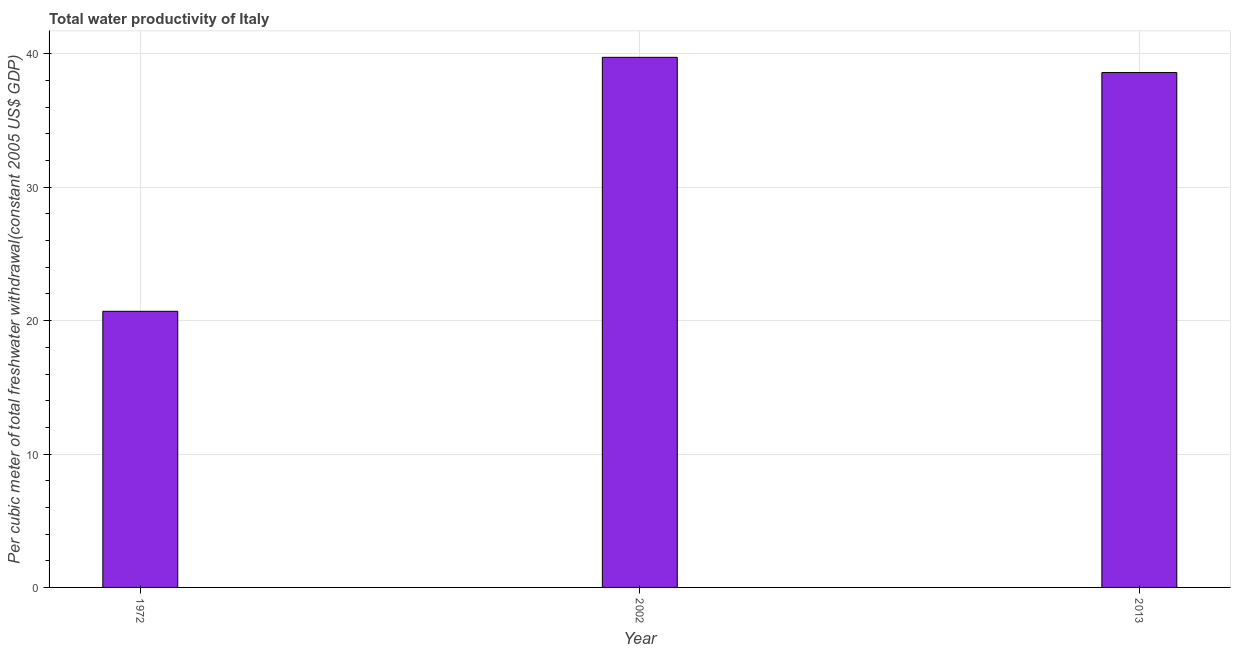Does the graph contain grids?
Offer a very short reply. Yes. What is the title of the graph?
Provide a succinct answer. Total water productivity of Italy. What is the label or title of the Y-axis?
Offer a terse response. Per cubic meter of total freshwater withdrawal(constant 2005 US$ GDP). What is the total water productivity in 2002?
Offer a very short reply. 39.74. Across all years, what is the maximum total water productivity?
Give a very brief answer. 39.74. Across all years, what is the minimum total water productivity?
Keep it short and to the point. 20.7. What is the sum of the total water productivity?
Your response must be concise. 99.05. What is the difference between the total water productivity in 1972 and 2002?
Give a very brief answer. -19.04. What is the average total water productivity per year?
Make the answer very short. 33.02. What is the median total water productivity?
Make the answer very short. 38.6. In how many years, is the total water productivity greater than 6 US$?
Give a very brief answer. 3. What is the ratio of the total water productivity in 1972 to that in 2002?
Your answer should be very brief. 0.52. Is the total water productivity in 1972 less than that in 2002?
Give a very brief answer. Yes. What is the difference between the highest and the second highest total water productivity?
Ensure brevity in your answer.  1.14. Is the sum of the total water productivity in 2002 and 2013 greater than the maximum total water productivity across all years?
Offer a very short reply. Yes. What is the difference between the highest and the lowest total water productivity?
Make the answer very short. 19.04. In how many years, is the total water productivity greater than the average total water productivity taken over all years?
Provide a succinct answer. 2. How many bars are there?
Your answer should be very brief. 3. How many years are there in the graph?
Ensure brevity in your answer.  3. What is the difference between two consecutive major ticks on the Y-axis?
Give a very brief answer. 10. What is the Per cubic meter of total freshwater withdrawal(constant 2005 US$ GDP) in 1972?
Keep it short and to the point. 20.7. What is the Per cubic meter of total freshwater withdrawal(constant 2005 US$ GDP) of 2002?
Your answer should be very brief. 39.74. What is the Per cubic meter of total freshwater withdrawal(constant 2005 US$ GDP) in 2013?
Your answer should be compact. 38.6. What is the difference between the Per cubic meter of total freshwater withdrawal(constant 2005 US$ GDP) in 1972 and 2002?
Make the answer very short. -19.04. What is the difference between the Per cubic meter of total freshwater withdrawal(constant 2005 US$ GDP) in 1972 and 2013?
Provide a short and direct response. -17.9. What is the difference between the Per cubic meter of total freshwater withdrawal(constant 2005 US$ GDP) in 2002 and 2013?
Provide a succinct answer. 1.14. What is the ratio of the Per cubic meter of total freshwater withdrawal(constant 2005 US$ GDP) in 1972 to that in 2002?
Your response must be concise. 0.52. What is the ratio of the Per cubic meter of total freshwater withdrawal(constant 2005 US$ GDP) in 1972 to that in 2013?
Offer a very short reply. 0.54. 